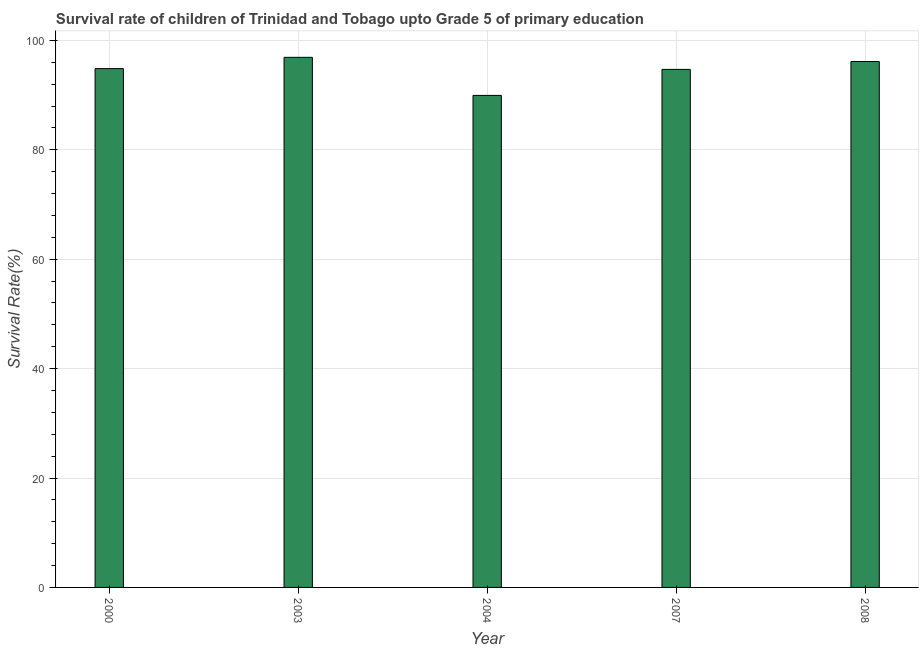Does the graph contain any zero values?
Provide a succinct answer. No. What is the title of the graph?
Provide a short and direct response. Survival rate of children of Trinidad and Tobago upto Grade 5 of primary education. What is the label or title of the Y-axis?
Offer a terse response. Survival Rate(%). What is the survival rate in 2008?
Make the answer very short. 96.14. Across all years, what is the maximum survival rate?
Offer a terse response. 96.91. Across all years, what is the minimum survival rate?
Your answer should be very brief. 89.94. In which year was the survival rate minimum?
Your answer should be compact. 2004. What is the sum of the survival rate?
Provide a short and direct response. 472.54. What is the difference between the survival rate in 2004 and 2007?
Your answer should be very brief. -4.76. What is the average survival rate per year?
Keep it short and to the point. 94.51. What is the median survival rate?
Provide a succinct answer. 94.84. Do a majority of the years between 2000 and 2007 (inclusive) have survival rate greater than 28 %?
Offer a very short reply. Yes. Is the survival rate in 2004 less than that in 2007?
Ensure brevity in your answer.  Yes. What is the difference between the highest and the second highest survival rate?
Your answer should be compact. 0.76. Is the sum of the survival rate in 2004 and 2007 greater than the maximum survival rate across all years?
Your response must be concise. Yes. What is the difference between the highest and the lowest survival rate?
Your answer should be compact. 6.96. In how many years, is the survival rate greater than the average survival rate taken over all years?
Make the answer very short. 4. How many years are there in the graph?
Make the answer very short. 5. What is the difference between two consecutive major ticks on the Y-axis?
Your answer should be compact. 20. What is the Survival Rate(%) in 2000?
Your answer should be very brief. 94.84. What is the Survival Rate(%) in 2003?
Ensure brevity in your answer.  96.91. What is the Survival Rate(%) in 2004?
Ensure brevity in your answer.  89.94. What is the Survival Rate(%) of 2007?
Your answer should be very brief. 94.7. What is the Survival Rate(%) in 2008?
Provide a short and direct response. 96.14. What is the difference between the Survival Rate(%) in 2000 and 2003?
Make the answer very short. -2.06. What is the difference between the Survival Rate(%) in 2000 and 2004?
Provide a short and direct response. 4.9. What is the difference between the Survival Rate(%) in 2000 and 2007?
Provide a short and direct response. 0.14. What is the difference between the Survival Rate(%) in 2000 and 2008?
Offer a terse response. -1.3. What is the difference between the Survival Rate(%) in 2003 and 2004?
Offer a very short reply. 6.96. What is the difference between the Survival Rate(%) in 2003 and 2007?
Give a very brief answer. 2.2. What is the difference between the Survival Rate(%) in 2003 and 2008?
Keep it short and to the point. 0.76. What is the difference between the Survival Rate(%) in 2004 and 2007?
Provide a succinct answer. -4.76. What is the difference between the Survival Rate(%) in 2004 and 2008?
Provide a succinct answer. -6.2. What is the difference between the Survival Rate(%) in 2007 and 2008?
Give a very brief answer. -1.44. What is the ratio of the Survival Rate(%) in 2000 to that in 2003?
Provide a succinct answer. 0.98. What is the ratio of the Survival Rate(%) in 2000 to that in 2004?
Your answer should be very brief. 1.05. What is the ratio of the Survival Rate(%) in 2000 to that in 2007?
Your response must be concise. 1. What is the ratio of the Survival Rate(%) in 2000 to that in 2008?
Your response must be concise. 0.99. What is the ratio of the Survival Rate(%) in 2003 to that in 2004?
Your answer should be compact. 1.08. What is the ratio of the Survival Rate(%) in 2003 to that in 2008?
Your response must be concise. 1.01. What is the ratio of the Survival Rate(%) in 2004 to that in 2008?
Provide a succinct answer. 0.94. What is the ratio of the Survival Rate(%) in 2007 to that in 2008?
Provide a short and direct response. 0.98. 